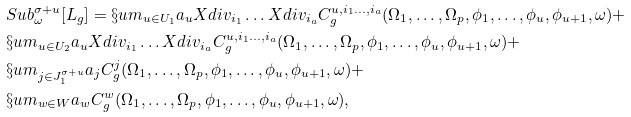Convert formula to latex. <formula><loc_0><loc_0><loc_500><loc_500>& S u b ^ { \sigma + u } _ { \omega } [ L _ { g } ] = \S u m _ { u \in U _ { 1 } } a _ { u } X d i v _ { i _ { 1 } } \dots X d i v _ { i _ { a } } C ^ { u , i _ { 1 } \dots , i _ { a } } _ { g } ( \Omega _ { 1 } , \dots , \Omega _ { p } , \phi _ { 1 } , \dots , \phi _ { u } , \phi _ { u + 1 } , \omega ) + \\ & \S u m _ { u \in U _ { 2 } } a _ { u } X d i v _ { i _ { 1 } } \dots X d i v _ { i _ { a } } C ^ { u , i _ { 1 } \dots , i _ { a } } _ { g } ( \Omega _ { 1 } , \dots , \Omega _ { p } , \phi _ { 1 } , \dots , \phi _ { u } , \phi _ { u + 1 } , \omega ) + \\ & \S u m _ { j \in J ^ { \sigma + u } _ { 1 } } a _ { j } C ^ { j } _ { g } ( \Omega _ { 1 } , \dots , \Omega _ { p } , \phi _ { 1 } , \dots , \phi _ { u } , \phi _ { u + 1 } , \omega ) + \\ & \S u m _ { w \in W } a _ { w } C ^ { w } _ { g } ( \Omega _ { 1 } , \dots , \Omega _ { p } , \phi _ { 1 } , \dots , \phi _ { u } , \phi _ { u + 1 } , \omega ) ,</formula> 